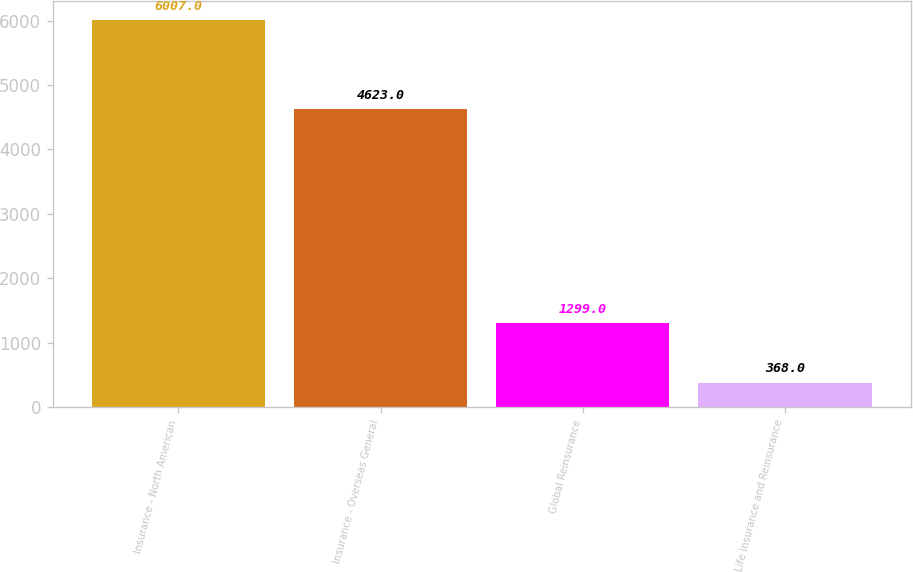Convert chart. <chart><loc_0><loc_0><loc_500><loc_500><bar_chart><fcel>Insurance - North American<fcel>Insurance - Overseas General<fcel>Global Reinsurance<fcel>Life Insurance and Reinsurance<nl><fcel>6007<fcel>4623<fcel>1299<fcel>368<nl></chart> 